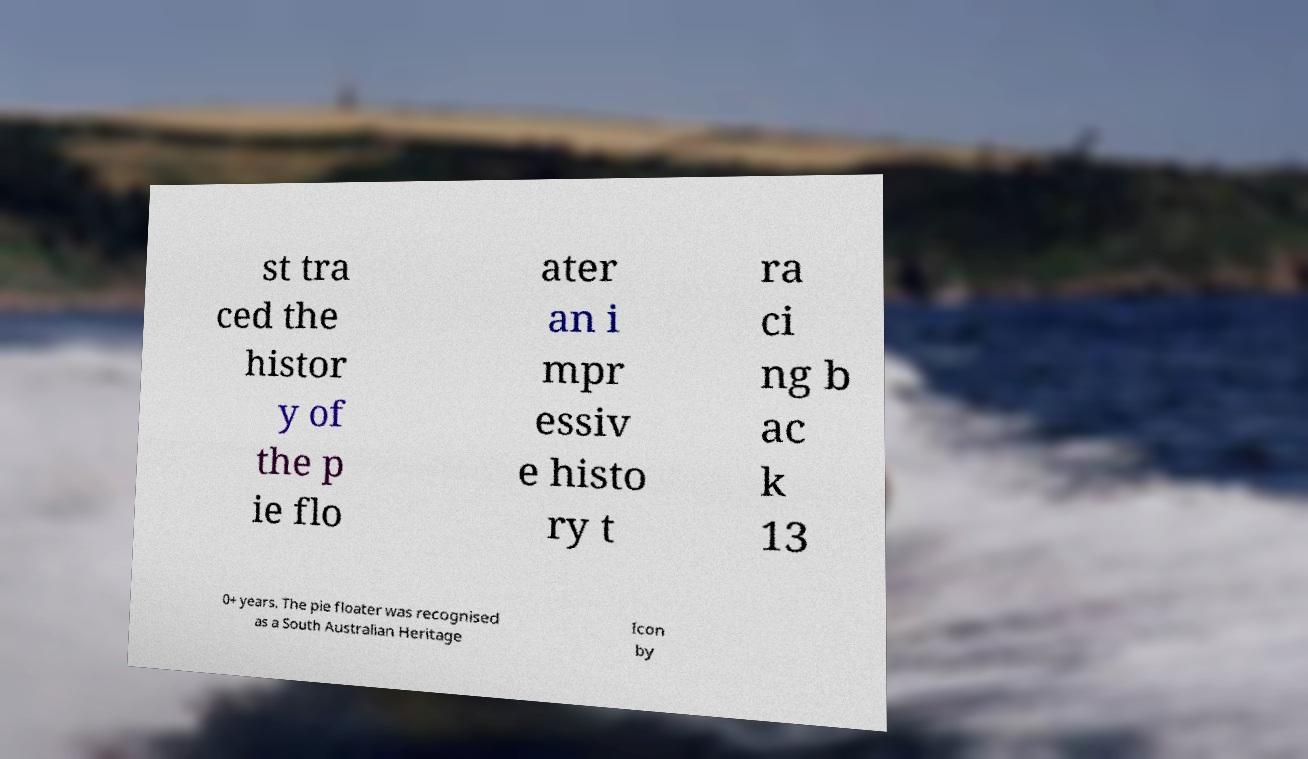Could you extract and type out the text from this image? st tra ced the histor y of the p ie flo ater an i mpr essiv e histo ry t ra ci ng b ac k 13 0+ years. The pie floater was recognised as a South Australian Heritage Icon by 